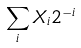<formula> <loc_0><loc_0><loc_500><loc_500>\sum _ { i } X _ { i } 2 ^ { - i }</formula> 